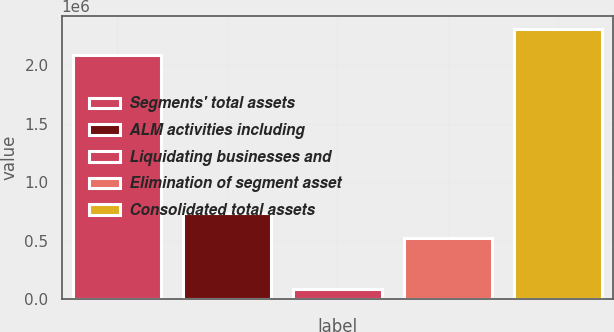Convert chart. <chart><loc_0><loc_0><loc_500><loc_500><bar_chart><fcel>Segments' total assets<fcel>ALM activities including<fcel>Liquidating businesses and<fcel>Elimination of segment asset<fcel>Consolidated total assets<nl><fcel>2.08719e+06<fcel>739671<fcel>89008<fcel>520448<fcel>2.30641e+06<nl></chart> 